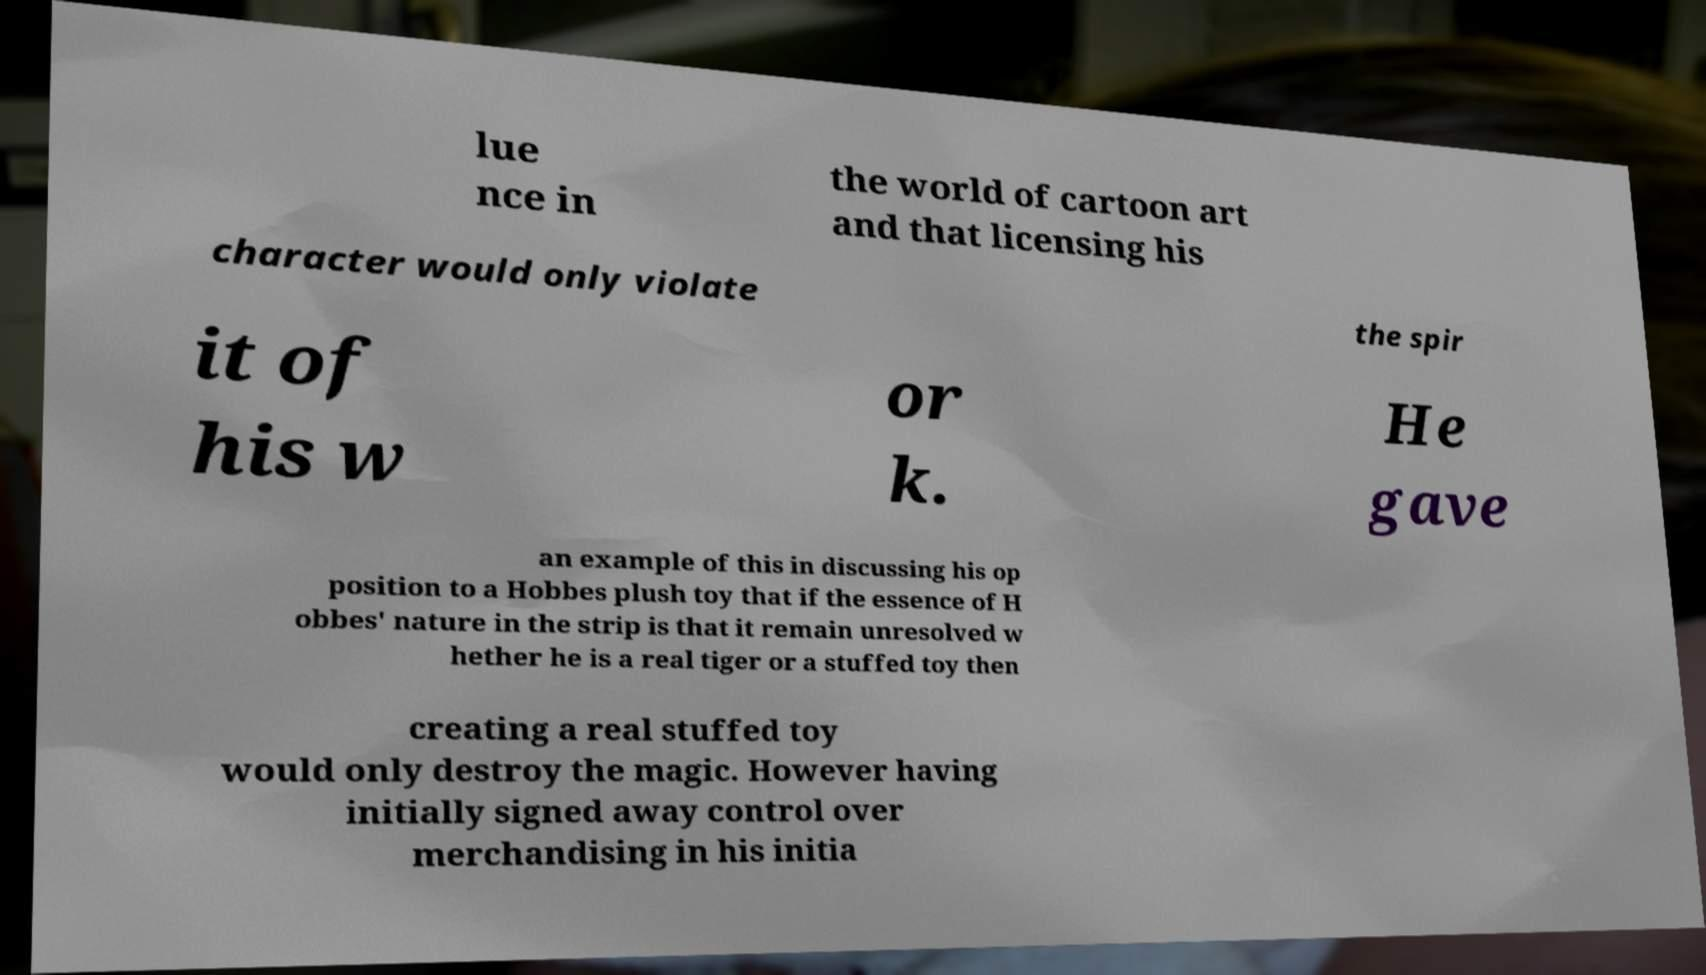Could you extract and type out the text from this image? lue nce in the world of cartoon art and that licensing his character would only violate the spir it of his w or k. He gave an example of this in discussing his op position to a Hobbes plush toy that if the essence of H obbes' nature in the strip is that it remain unresolved w hether he is a real tiger or a stuffed toy then creating a real stuffed toy would only destroy the magic. However having initially signed away control over merchandising in his initia 